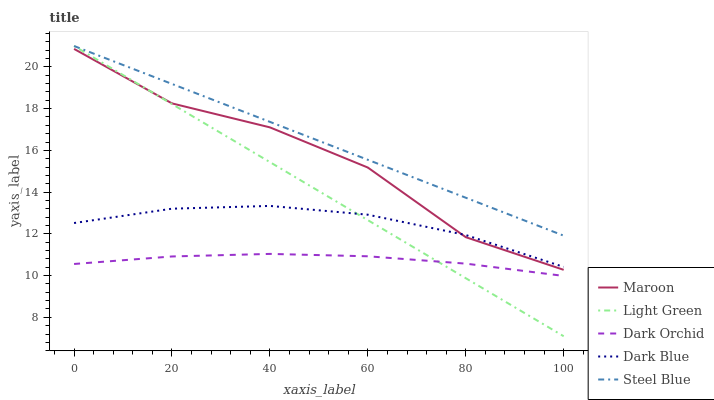Does Dark Orchid have the minimum area under the curve?
Answer yes or no. Yes. Does Steel Blue have the maximum area under the curve?
Answer yes or no. Yes. Does Dark Blue have the minimum area under the curve?
Answer yes or no. No. Does Dark Blue have the maximum area under the curve?
Answer yes or no. No. Is Light Green the smoothest?
Answer yes or no. Yes. Is Maroon the roughest?
Answer yes or no. Yes. Is Dark Blue the smoothest?
Answer yes or no. No. Is Dark Blue the roughest?
Answer yes or no. No. Does Light Green have the lowest value?
Answer yes or no. Yes. Does Dark Blue have the lowest value?
Answer yes or no. No. Does Steel Blue have the highest value?
Answer yes or no. Yes. Does Dark Blue have the highest value?
Answer yes or no. No. Is Maroon less than Steel Blue?
Answer yes or no. Yes. Is Steel Blue greater than Dark Blue?
Answer yes or no. Yes. Does Dark Orchid intersect Light Green?
Answer yes or no. Yes. Is Dark Orchid less than Light Green?
Answer yes or no. No. Is Dark Orchid greater than Light Green?
Answer yes or no. No. Does Maroon intersect Steel Blue?
Answer yes or no. No. 